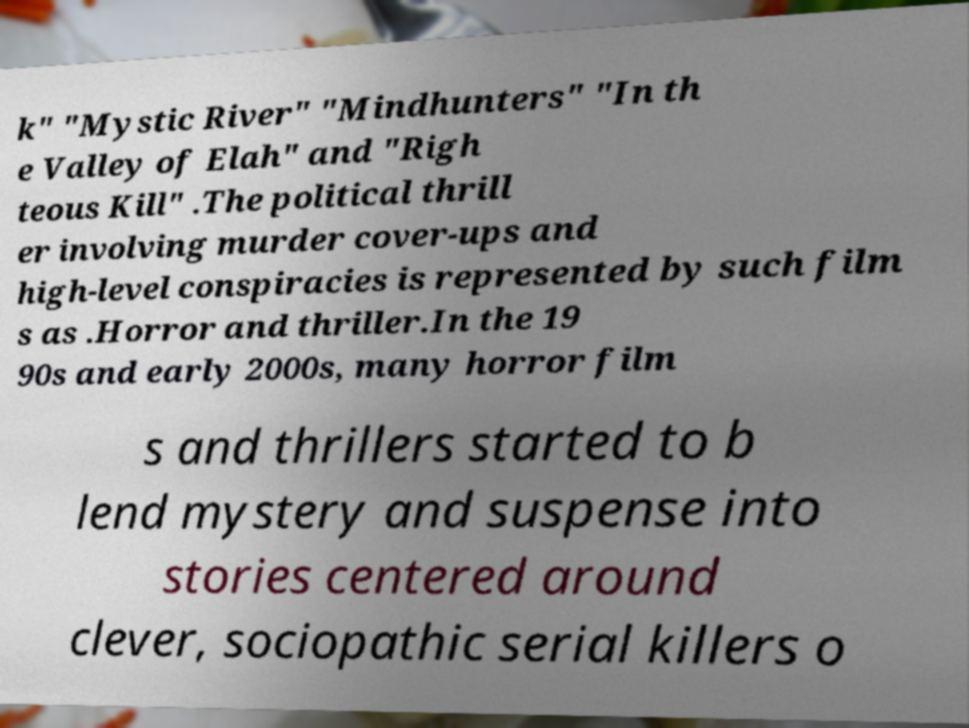Could you assist in decoding the text presented in this image and type it out clearly? k" "Mystic River" "Mindhunters" "In th e Valley of Elah" and "Righ teous Kill" .The political thrill er involving murder cover-ups and high-level conspiracies is represented by such film s as .Horror and thriller.In the 19 90s and early 2000s, many horror film s and thrillers started to b lend mystery and suspense into stories centered around clever, sociopathic serial killers o 